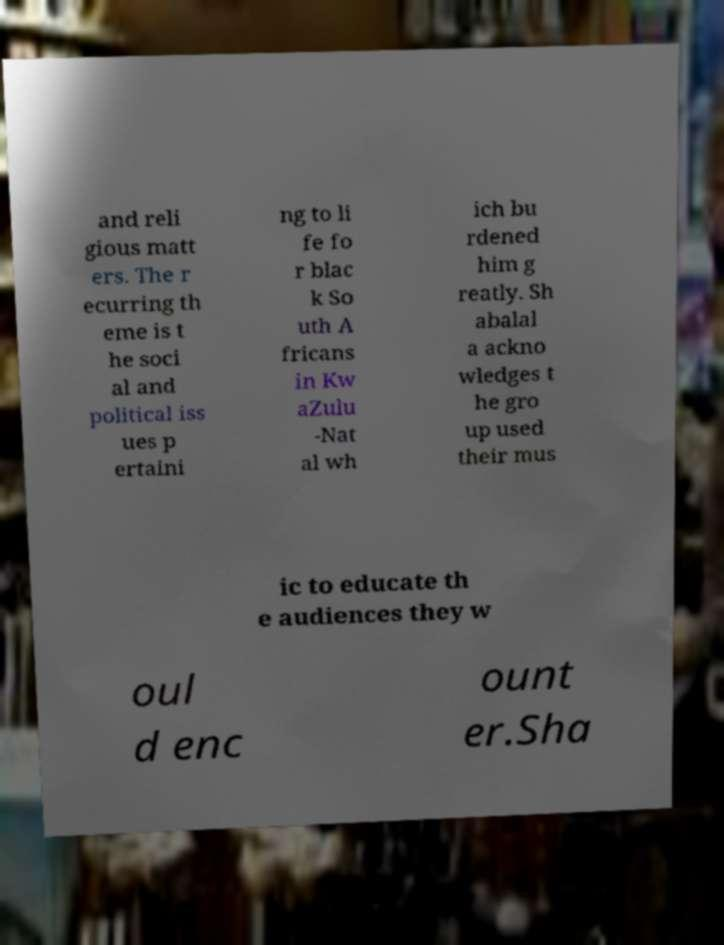There's text embedded in this image that I need extracted. Can you transcribe it verbatim? and reli gious matt ers. The r ecurring th eme is t he soci al and political iss ues p ertaini ng to li fe fo r blac k So uth A fricans in Kw aZulu -Nat al wh ich bu rdened him g reatly. Sh abalal a ackno wledges t he gro up used their mus ic to educate th e audiences they w oul d enc ount er.Sha 